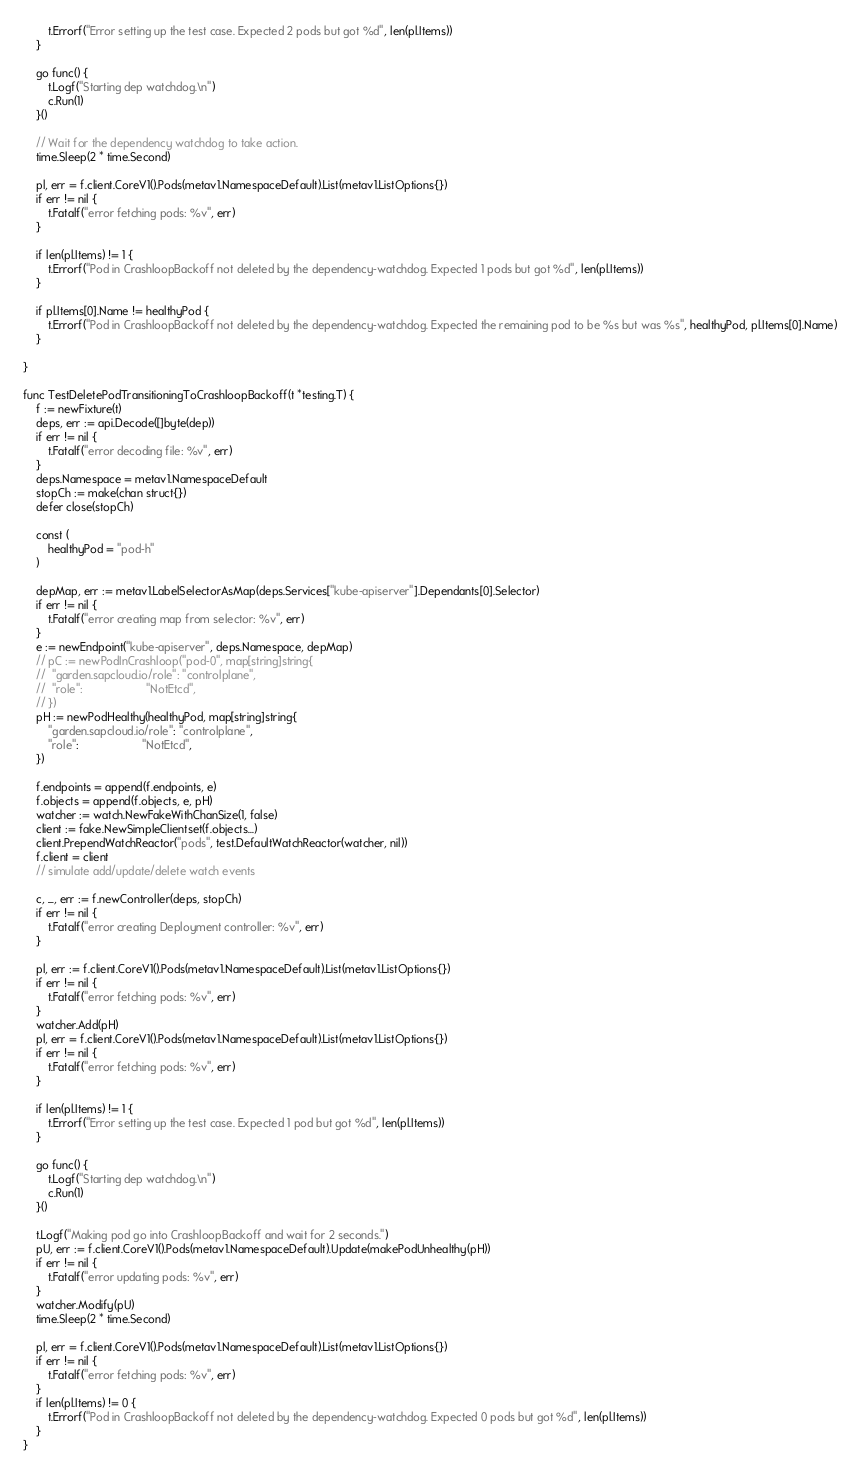<code> <loc_0><loc_0><loc_500><loc_500><_Go_>		t.Errorf("Error setting up the test case. Expected 2 pods but got %d", len(pl.Items))
	}

	go func() {
		t.Logf("Starting dep watchdog.\n")
		c.Run(1)
	}()

	// Wait for the dependency watchdog to take action.
	time.Sleep(2 * time.Second)

	pl, err = f.client.CoreV1().Pods(metav1.NamespaceDefault).List(metav1.ListOptions{})
	if err != nil {
		t.Fatalf("error fetching pods: %v", err)
	}

	if len(pl.Items) != 1 {
		t.Errorf("Pod in CrashloopBackoff not deleted by the dependency-watchdog. Expected 1 pods but got %d", len(pl.Items))
	}

	if pl.Items[0].Name != healthyPod {
		t.Errorf("Pod in CrashloopBackoff not deleted by the dependency-watchdog. Expected the remaining pod to be %s but was %s", healthyPod, pl.Items[0].Name)
	}

}

func TestDeletePodTransitioningToCrashloopBackoff(t *testing.T) {
	f := newFixture(t)
	deps, err := api.Decode([]byte(dep))
	if err != nil {
		t.Fatalf("error decoding file: %v", err)
	}
	deps.Namespace = metav1.NamespaceDefault
	stopCh := make(chan struct{})
	defer close(stopCh)

	const (
		healthyPod = "pod-h"
	)

	depMap, err := metav1.LabelSelectorAsMap(deps.Services["kube-apiserver"].Dependants[0].Selector)
	if err != nil {
		t.Fatalf("error creating map from selector: %v", err)
	}
	e := newEndpoint("kube-apiserver", deps.Namespace, depMap)
	// pC := newPodInCrashloop("pod-0", map[string]string{
	// 	"garden.sapcloud.io/role": "controlplane",
	// 	"role":                    "NotEtcd",
	// })
	pH := newPodHealthy(healthyPod, map[string]string{
		"garden.sapcloud.io/role": "controlplane",
		"role":                    "NotEtcd",
	})

	f.endpoints = append(f.endpoints, e)
	f.objects = append(f.objects, e, pH)
	watcher := watch.NewFakeWithChanSize(1, false)
	client := fake.NewSimpleClientset(f.objects...)
	client.PrependWatchReactor("pods", test.DefaultWatchReactor(watcher, nil))
	f.client = client
	// simulate add/update/delete watch events

	c, _, err := f.newController(deps, stopCh)
	if err != nil {
		t.Fatalf("error creating Deployment controller: %v", err)
	}

	pl, err := f.client.CoreV1().Pods(metav1.NamespaceDefault).List(metav1.ListOptions{})
	if err != nil {
		t.Fatalf("error fetching pods: %v", err)
	}
	watcher.Add(pH)
	pl, err = f.client.CoreV1().Pods(metav1.NamespaceDefault).List(metav1.ListOptions{})
	if err != nil {
		t.Fatalf("error fetching pods: %v", err)
	}

	if len(pl.Items) != 1 {
		t.Errorf("Error setting up the test case. Expected 1 pod but got %d", len(pl.Items))
	}

	go func() {
		t.Logf("Starting dep watchdog.\n")
		c.Run(1)
	}()

	t.Logf("Making pod go into CrashloopBackoff and wait for 2 seconds.")
	pU, err := f.client.CoreV1().Pods(metav1.NamespaceDefault).Update(makePodUnhealthy(pH))
	if err != nil {
		t.Fatalf("error updating pods: %v", err)
	}
	watcher.Modify(pU)
	time.Sleep(2 * time.Second)

	pl, err = f.client.CoreV1().Pods(metav1.NamespaceDefault).List(metav1.ListOptions{})
	if err != nil {
		t.Fatalf("error fetching pods: %v", err)
	}
	if len(pl.Items) != 0 {
		t.Errorf("Pod in CrashloopBackoff not deleted by the dependency-watchdog. Expected 0 pods but got %d", len(pl.Items))
	}
}
</code> 